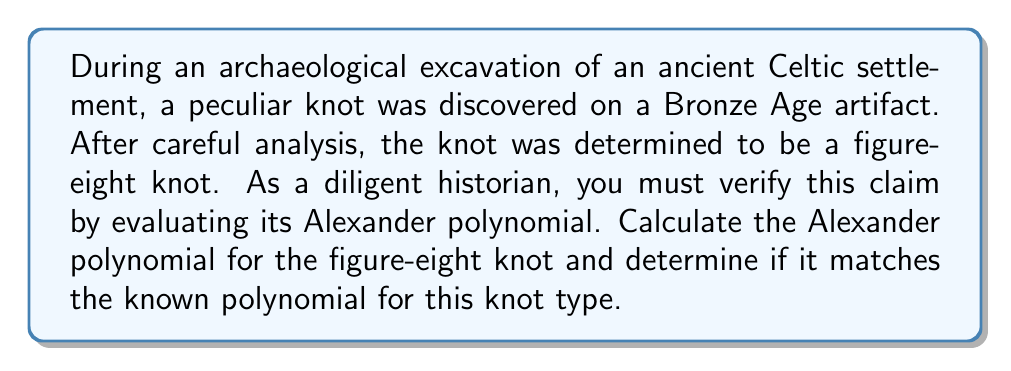Provide a solution to this math problem. To evaluate the Alexander polynomial for the figure-eight knot, we'll follow these steps:

1. Draw the knot diagram:
[asy]
import geometry;

pair[] points = {(0,0), (1,1), (0,2), (-1,1)};
path knot = points[0]--points[1]--points[2]--points[3]--cycle;

draw(knot, linewidth(2));
draw(shift(0.1,0.1)*knot, white+linewidth(4));
draw(shift(0.1,0.1)*knot, linewidth(2));

dot(points, linewidth(4));
[/asy]

2. Label the arcs and crossings:
[asy]
import geometry;

pair[] points = {(0,0), (1,1), (0,2), (-1,1)};
path knot = points[0]--points[1]--points[2]--points[3]--cycle;

draw(knot, linewidth(2));
draw(shift(0.1,0.1)*knot, white+linewidth(4));
draw(shift(0.1,0.1)*knot, linewidth(2));

dot(points, linewidth(4));

label("a", (0.5,0.5), E);
label("b", (-0.5,1.5), W);
label("c", (0.5,1.5), E);
label("d", (-0.5,0.5), W);

label("1", (0,0), SW);
label("2", (0,2), NE);
label("3", (-1,1), NW);
label("4", (1,1), SE);
[/asy]

3. Create the crossing matrix:
$$
\begin{pmatrix}
1-t & t & 0 & -1 \\
-1 & 1-t & t & 0 \\
t & 0 & -1 & 1-t \\
0 & -1 & 1-t & t
\end{pmatrix}
$$

4. Calculate the determinant of any 3x3 minor:
Let's choose the minor obtained by removing the first row and first column:
$$
\Delta(t) = \begin{vmatrix}
1-t & t & 0 \\
0 & -1 & 1-t \\
-1 & 1-t & t
\end{vmatrix}
$$

5. Expand the determinant:
$$
\begin{align}
\Delta(t) &= (1-t)(-1)(t) + t(-1)(1-t) + 0 \\
&= -t+t^2 -t+t^2 \\
&= -2t + 2t^2
\end{align}
$$

6. Normalize the polynomial:
Divide by the lowest degree term and multiply by -1 to make the constant term positive:
$$
\Delta(t) = 2t^2 - 2t = 2t(t-1) = -2t(1-t)
$$
Normalizing:
$$
\Delta(t) = 1 - t + t^2
$$

7. Verify the result:
The Alexander polynomial for the figure-eight knot is indeed $1 - t + t^2$, which matches our calculated result.
Answer: $1 - t + t^2$ 